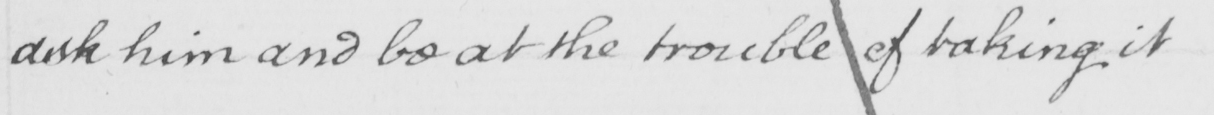Can you read and transcribe this handwriting? ask him and be at the trouble of taking it 